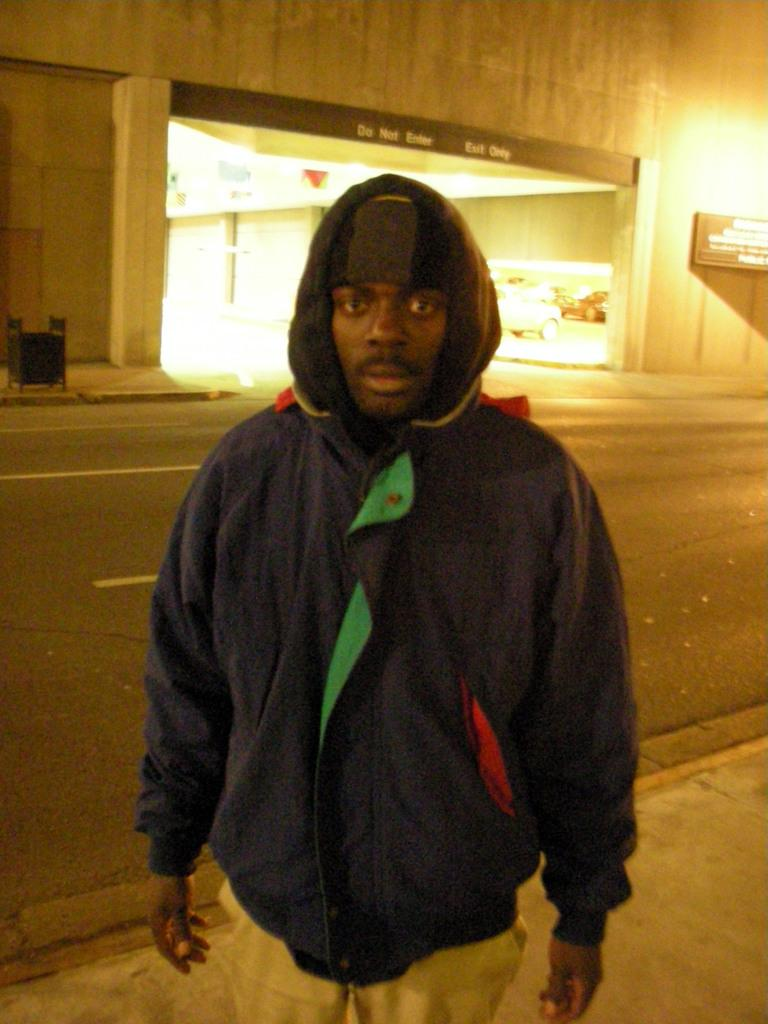What is the person in the image wearing? The person is wearing a jacket. What direction is the person looking in the image? The person is looking forward. What can be seen in the background of the image? There is a wall and a road in the background. What type of attack is the person preparing for in the image? There is no indication of an attack or any preparations for one in the image. 